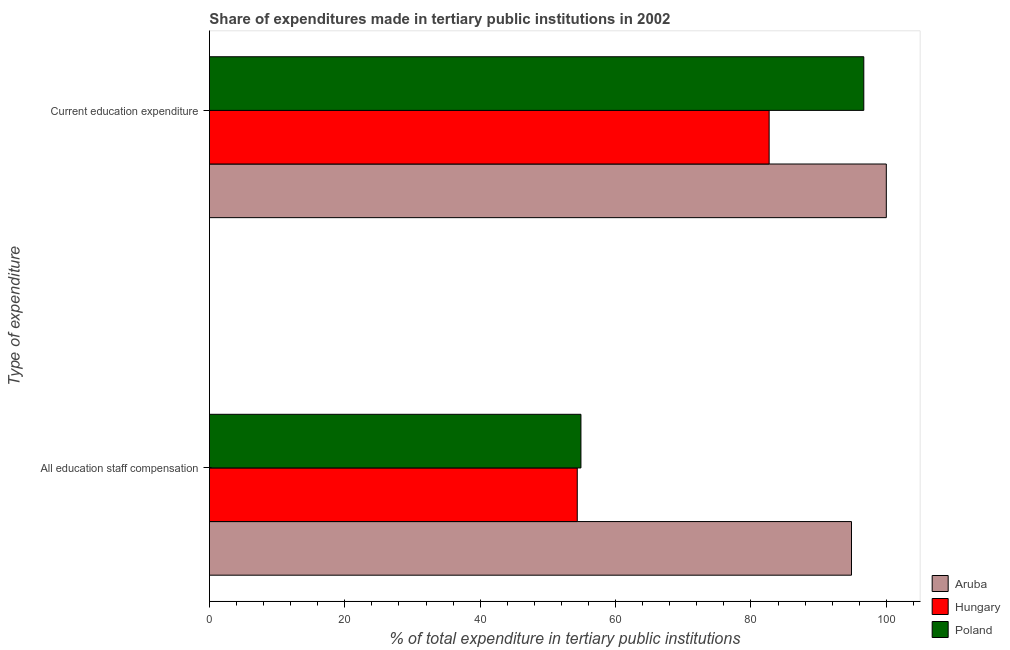How many groups of bars are there?
Give a very brief answer. 2. Are the number of bars per tick equal to the number of legend labels?
Give a very brief answer. Yes. What is the label of the 2nd group of bars from the top?
Your response must be concise. All education staff compensation. What is the expenditure in education in Hungary?
Make the answer very short. 82.69. Across all countries, what is the maximum expenditure in staff compensation?
Offer a terse response. 94.85. Across all countries, what is the minimum expenditure in education?
Provide a succinct answer. 82.69. In which country was the expenditure in education maximum?
Keep it short and to the point. Aruba. In which country was the expenditure in education minimum?
Your answer should be compact. Hungary. What is the total expenditure in staff compensation in the graph?
Give a very brief answer. 204.08. What is the difference between the expenditure in staff compensation in Poland and that in Hungary?
Offer a terse response. 0.54. What is the difference between the expenditure in education in Aruba and the expenditure in staff compensation in Poland?
Give a very brief answer. 45.11. What is the average expenditure in staff compensation per country?
Offer a very short reply. 68.03. What is the difference between the expenditure in education and expenditure in staff compensation in Hungary?
Ensure brevity in your answer.  28.34. In how many countries, is the expenditure in education greater than 40 %?
Your response must be concise. 3. What is the ratio of the expenditure in education in Aruba to that in Hungary?
Ensure brevity in your answer.  1.21. In how many countries, is the expenditure in staff compensation greater than the average expenditure in staff compensation taken over all countries?
Provide a short and direct response. 1. What does the 3rd bar from the top in All education staff compensation represents?
Provide a succinct answer. Aruba. What does the 2nd bar from the bottom in Current education expenditure represents?
Offer a terse response. Hungary. Does the graph contain grids?
Provide a succinct answer. No. How are the legend labels stacked?
Make the answer very short. Vertical. What is the title of the graph?
Offer a terse response. Share of expenditures made in tertiary public institutions in 2002. Does "Micronesia" appear as one of the legend labels in the graph?
Keep it short and to the point. No. What is the label or title of the X-axis?
Your answer should be compact. % of total expenditure in tertiary public institutions. What is the label or title of the Y-axis?
Give a very brief answer. Type of expenditure. What is the % of total expenditure in tertiary public institutions of Aruba in All education staff compensation?
Offer a terse response. 94.85. What is the % of total expenditure in tertiary public institutions in Hungary in All education staff compensation?
Make the answer very short. 54.34. What is the % of total expenditure in tertiary public institutions in Poland in All education staff compensation?
Your answer should be compact. 54.89. What is the % of total expenditure in tertiary public institutions in Aruba in Current education expenditure?
Provide a short and direct response. 100. What is the % of total expenditure in tertiary public institutions in Hungary in Current education expenditure?
Give a very brief answer. 82.69. What is the % of total expenditure in tertiary public institutions in Poland in Current education expenditure?
Your answer should be very brief. 96.67. Across all Type of expenditure, what is the maximum % of total expenditure in tertiary public institutions of Aruba?
Make the answer very short. 100. Across all Type of expenditure, what is the maximum % of total expenditure in tertiary public institutions in Hungary?
Give a very brief answer. 82.69. Across all Type of expenditure, what is the maximum % of total expenditure in tertiary public institutions in Poland?
Ensure brevity in your answer.  96.67. Across all Type of expenditure, what is the minimum % of total expenditure in tertiary public institutions of Aruba?
Your answer should be very brief. 94.85. Across all Type of expenditure, what is the minimum % of total expenditure in tertiary public institutions in Hungary?
Ensure brevity in your answer.  54.34. Across all Type of expenditure, what is the minimum % of total expenditure in tertiary public institutions of Poland?
Ensure brevity in your answer.  54.89. What is the total % of total expenditure in tertiary public institutions of Aruba in the graph?
Give a very brief answer. 194.85. What is the total % of total expenditure in tertiary public institutions of Hungary in the graph?
Ensure brevity in your answer.  137.03. What is the total % of total expenditure in tertiary public institutions of Poland in the graph?
Offer a terse response. 151.56. What is the difference between the % of total expenditure in tertiary public institutions of Aruba in All education staff compensation and that in Current education expenditure?
Give a very brief answer. -5.15. What is the difference between the % of total expenditure in tertiary public institutions in Hungary in All education staff compensation and that in Current education expenditure?
Your answer should be compact. -28.34. What is the difference between the % of total expenditure in tertiary public institutions in Poland in All education staff compensation and that in Current education expenditure?
Ensure brevity in your answer.  -41.79. What is the difference between the % of total expenditure in tertiary public institutions in Aruba in All education staff compensation and the % of total expenditure in tertiary public institutions in Hungary in Current education expenditure?
Make the answer very short. 12.16. What is the difference between the % of total expenditure in tertiary public institutions of Aruba in All education staff compensation and the % of total expenditure in tertiary public institutions of Poland in Current education expenditure?
Make the answer very short. -1.82. What is the difference between the % of total expenditure in tertiary public institutions in Hungary in All education staff compensation and the % of total expenditure in tertiary public institutions in Poland in Current education expenditure?
Offer a terse response. -42.33. What is the average % of total expenditure in tertiary public institutions of Aruba per Type of expenditure?
Offer a terse response. 97.43. What is the average % of total expenditure in tertiary public institutions of Hungary per Type of expenditure?
Offer a very short reply. 68.52. What is the average % of total expenditure in tertiary public institutions of Poland per Type of expenditure?
Offer a terse response. 75.78. What is the difference between the % of total expenditure in tertiary public institutions of Aruba and % of total expenditure in tertiary public institutions of Hungary in All education staff compensation?
Your answer should be very brief. 40.51. What is the difference between the % of total expenditure in tertiary public institutions in Aruba and % of total expenditure in tertiary public institutions in Poland in All education staff compensation?
Offer a very short reply. 39.97. What is the difference between the % of total expenditure in tertiary public institutions in Hungary and % of total expenditure in tertiary public institutions in Poland in All education staff compensation?
Give a very brief answer. -0.54. What is the difference between the % of total expenditure in tertiary public institutions in Aruba and % of total expenditure in tertiary public institutions in Hungary in Current education expenditure?
Your answer should be compact. 17.31. What is the difference between the % of total expenditure in tertiary public institutions in Aruba and % of total expenditure in tertiary public institutions in Poland in Current education expenditure?
Your answer should be compact. 3.33. What is the difference between the % of total expenditure in tertiary public institutions in Hungary and % of total expenditure in tertiary public institutions in Poland in Current education expenditure?
Give a very brief answer. -13.98. What is the ratio of the % of total expenditure in tertiary public institutions of Aruba in All education staff compensation to that in Current education expenditure?
Your answer should be compact. 0.95. What is the ratio of the % of total expenditure in tertiary public institutions of Hungary in All education staff compensation to that in Current education expenditure?
Keep it short and to the point. 0.66. What is the ratio of the % of total expenditure in tertiary public institutions in Poland in All education staff compensation to that in Current education expenditure?
Make the answer very short. 0.57. What is the difference between the highest and the second highest % of total expenditure in tertiary public institutions in Aruba?
Make the answer very short. 5.15. What is the difference between the highest and the second highest % of total expenditure in tertiary public institutions of Hungary?
Make the answer very short. 28.34. What is the difference between the highest and the second highest % of total expenditure in tertiary public institutions in Poland?
Keep it short and to the point. 41.79. What is the difference between the highest and the lowest % of total expenditure in tertiary public institutions of Aruba?
Make the answer very short. 5.15. What is the difference between the highest and the lowest % of total expenditure in tertiary public institutions in Hungary?
Provide a short and direct response. 28.34. What is the difference between the highest and the lowest % of total expenditure in tertiary public institutions of Poland?
Make the answer very short. 41.79. 